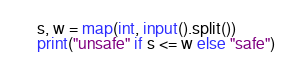<code> <loc_0><loc_0><loc_500><loc_500><_Python_>s, w = map(int, input().split())
print("unsafe" if s <= w else "safe")</code> 